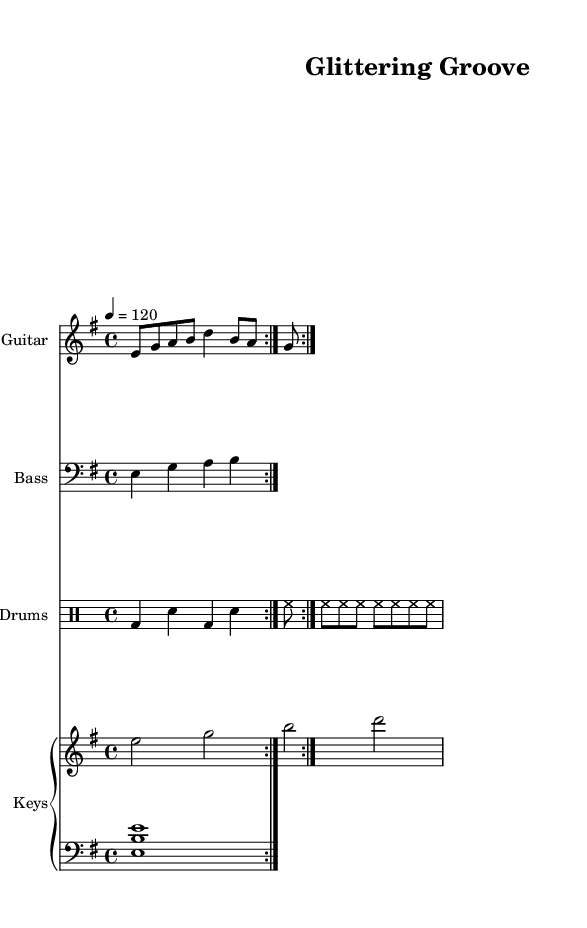What is the key signature of this music? The key signature indicates the notes that are sharp or flat in the piece. Here, it shows one sharp on the F line of the treble clef, making it E minor.
Answer: E minor What is the time signature of this piece? The time signature, found at the beginning of the sheet music, is 4/4, indicating four beats per measure and a quarter note gets one beat.
Answer: 4/4 What is the tempo marking for this track? The tempo marking indicates the speed of the music, measured in beats per minute. It shows "4 = 120," meaning feel four beats at a pace of 120 beats per minute.
Answer: 120 How many measures are in the guitar part before repeating? The guitar part has a repeat indication with "volta 2," meaning it is played through two times; the total measures can be counted in the music notation provided. There are 8 measures before the repeat.
Answer: 8 What instruments are used in this funk track? The piece lists four instruments at the beginning: Guitar, Bass, Drums, and Keys. Each instrument is separated in different staffs, showcasing their individual parts.
Answer: Guitar, Bass, Drums, Keys How does the bass line relate to the guitar riffs? The bass line provides a harmonic foundation and rhythmic support for the guitar riffs, which play more melodic content. Analyzing both parts shows they complement each other in the groove.
Answer: Complementary 